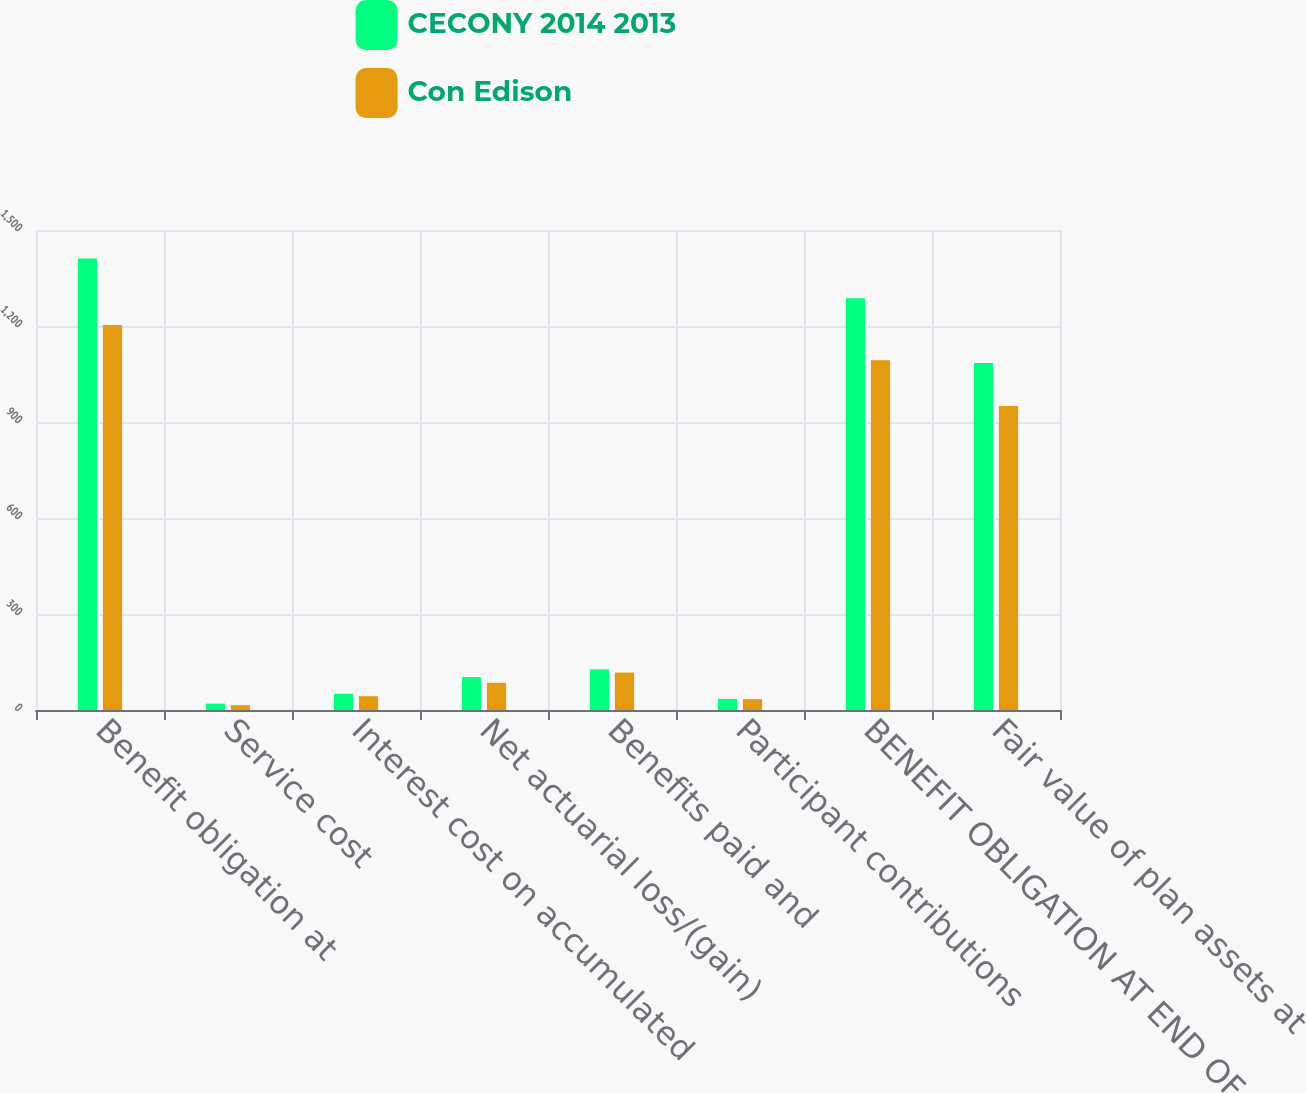Convert chart to OTSL. <chart><loc_0><loc_0><loc_500><loc_500><stacked_bar_chart><ecel><fcel>Benefit obligation at<fcel>Service cost<fcel>Interest cost on accumulated<fcel>Net actuarial loss/(gain)<fcel>Benefits paid and<fcel>Participant contributions<fcel>BENEFIT OBLIGATION AT END OF<fcel>Fair value of plan assets at<nl><fcel>CECONY 2014 2013<fcel>1411<fcel>20<fcel>51<fcel>103<fcel>127<fcel>35<fcel>1287<fcel>1084<nl><fcel>Con Edison<fcel>1203<fcel>15<fcel>43<fcel>85<fcel>117<fcel>34<fcel>1093<fcel>950<nl></chart> 